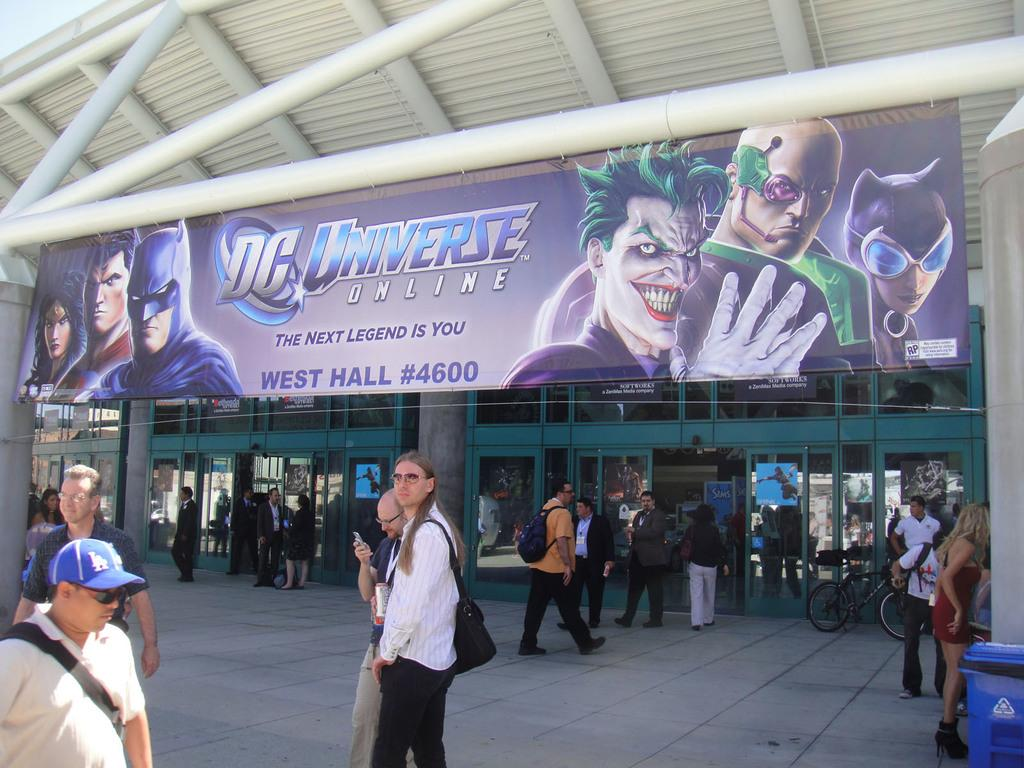<image>
Offer a succinct explanation of the picture presented. A crowd of people are flowing in and out of an arena that has a large sign that says DC Universe. 